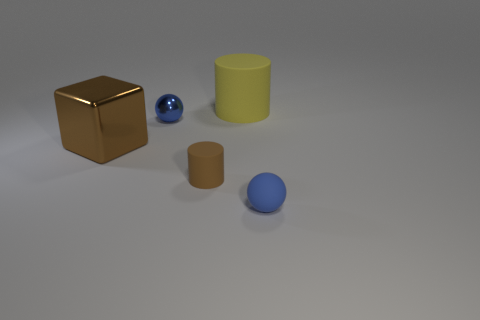Add 2 red blocks. How many objects exist? 7 Subtract all cylinders. How many objects are left? 3 Add 5 large blue matte objects. How many large blue matte objects exist? 5 Subtract 1 brown cylinders. How many objects are left? 4 Subtract all small brown metallic blocks. Subtract all spheres. How many objects are left? 3 Add 4 small blue balls. How many small blue balls are left? 6 